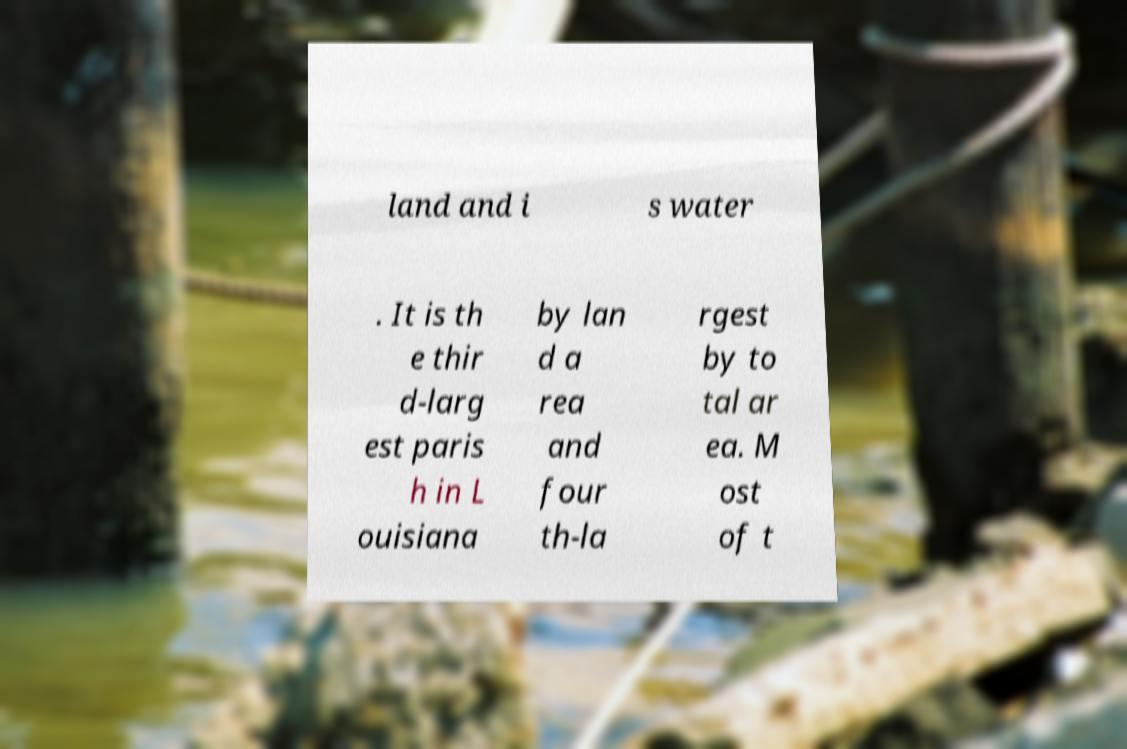What messages or text are displayed in this image? I need them in a readable, typed format. land and i s water . It is th e thir d-larg est paris h in L ouisiana by lan d a rea and four th-la rgest by to tal ar ea. M ost of t 